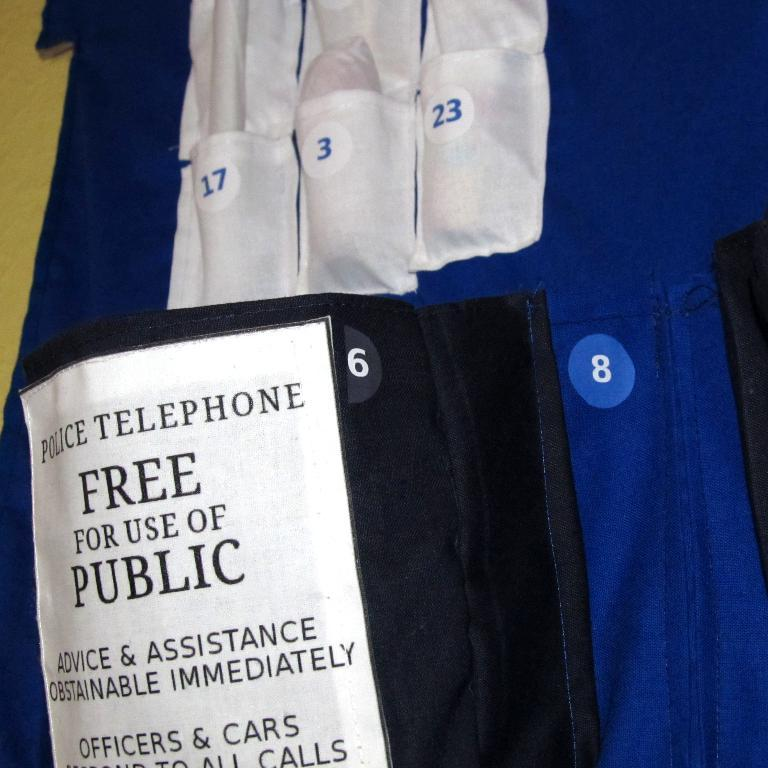<image>
Describe the image concisely. A sign offering a police phone for public use mentions it is free. 